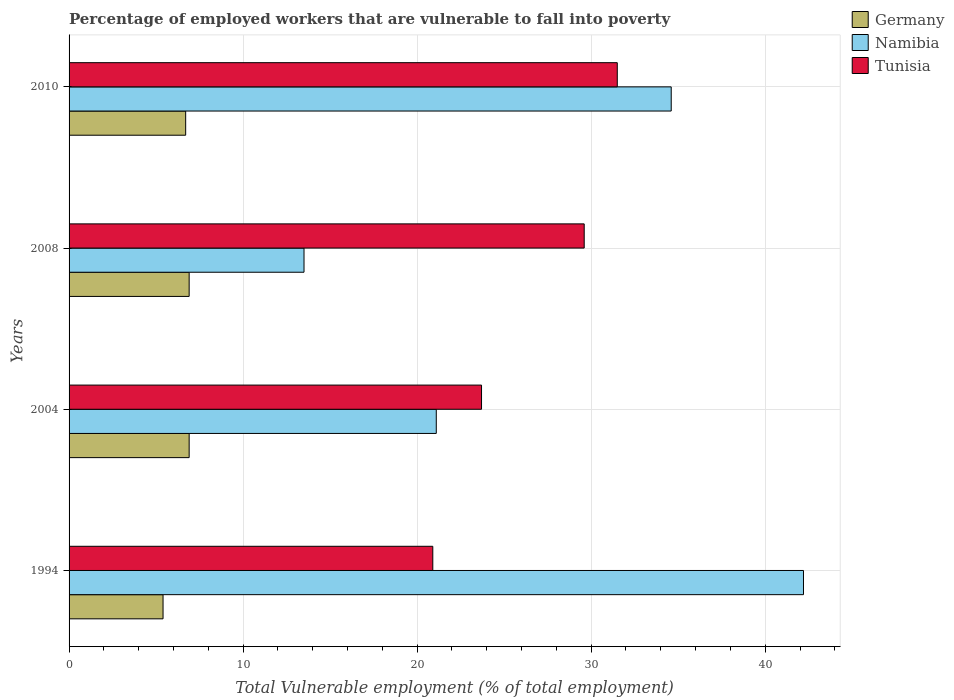Are the number of bars per tick equal to the number of legend labels?
Keep it short and to the point. Yes. How many bars are there on the 3rd tick from the top?
Your response must be concise. 3. How many bars are there on the 3rd tick from the bottom?
Provide a short and direct response. 3. What is the label of the 3rd group of bars from the top?
Offer a terse response. 2004. In how many cases, is the number of bars for a given year not equal to the number of legend labels?
Your response must be concise. 0. What is the percentage of employed workers who are vulnerable to fall into poverty in Germany in 2008?
Offer a very short reply. 6.9. Across all years, what is the maximum percentage of employed workers who are vulnerable to fall into poverty in Namibia?
Give a very brief answer. 42.2. Across all years, what is the minimum percentage of employed workers who are vulnerable to fall into poverty in Tunisia?
Provide a succinct answer. 20.9. In which year was the percentage of employed workers who are vulnerable to fall into poverty in Tunisia minimum?
Your answer should be compact. 1994. What is the total percentage of employed workers who are vulnerable to fall into poverty in Tunisia in the graph?
Provide a short and direct response. 105.7. What is the difference between the percentage of employed workers who are vulnerable to fall into poverty in Tunisia in 1994 and that in 2010?
Give a very brief answer. -10.6. What is the difference between the percentage of employed workers who are vulnerable to fall into poverty in Germany in 2010 and the percentage of employed workers who are vulnerable to fall into poverty in Namibia in 2008?
Give a very brief answer. -6.8. What is the average percentage of employed workers who are vulnerable to fall into poverty in Tunisia per year?
Keep it short and to the point. 26.43. In the year 2010, what is the difference between the percentage of employed workers who are vulnerable to fall into poverty in Germany and percentage of employed workers who are vulnerable to fall into poverty in Tunisia?
Your answer should be compact. -24.8. What is the ratio of the percentage of employed workers who are vulnerable to fall into poverty in Germany in 1994 to that in 2010?
Give a very brief answer. 0.81. Is the percentage of employed workers who are vulnerable to fall into poverty in Tunisia in 1994 less than that in 2004?
Your response must be concise. Yes. What is the difference between the highest and the lowest percentage of employed workers who are vulnerable to fall into poverty in Namibia?
Your answer should be very brief. 28.7. In how many years, is the percentage of employed workers who are vulnerable to fall into poverty in Namibia greater than the average percentage of employed workers who are vulnerable to fall into poverty in Namibia taken over all years?
Make the answer very short. 2. What does the 1st bar from the top in 2008 represents?
Provide a short and direct response. Tunisia. What does the 1st bar from the bottom in 1994 represents?
Your answer should be very brief. Germany. Is it the case that in every year, the sum of the percentage of employed workers who are vulnerable to fall into poverty in Namibia and percentage of employed workers who are vulnerable to fall into poverty in Germany is greater than the percentage of employed workers who are vulnerable to fall into poverty in Tunisia?
Give a very brief answer. No. How many bars are there?
Your answer should be compact. 12. Are all the bars in the graph horizontal?
Provide a short and direct response. Yes. How many years are there in the graph?
Your answer should be very brief. 4. How are the legend labels stacked?
Keep it short and to the point. Vertical. What is the title of the graph?
Make the answer very short. Percentage of employed workers that are vulnerable to fall into poverty. Does "Sweden" appear as one of the legend labels in the graph?
Provide a succinct answer. No. What is the label or title of the X-axis?
Give a very brief answer. Total Vulnerable employment (% of total employment). What is the label or title of the Y-axis?
Offer a terse response. Years. What is the Total Vulnerable employment (% of total employment) in Germany in 1994?
Keep it short and to the point. 5.4. What is the Total Vulnerable employment (% of total employment) of Namibia in 1994?
Keep it short and to the point. 42.2. What is the Total Vulnerable employment (% of total employment) of Tunisia in 1994?
Provide a succinct answer. 20.9. What is the Total Vulnerable employment (% of total employment) of Germany in 2004?
Your answer should be very brief. 6.9. What is the Total Vulnerable employment (% of total employment) in Namibia in 2004?
Provide a short and direct response. 21.1. What is the Total Vulnerable employment (% of total employment) in Tunisia in 2004?
Keep it short and to the point. 23.7. What is the Total Vulnerable employment (% of total employment) of Germany in 2008?
Your answer should be compact. 6.9. What is the Total Vulnerable employment (% of total employment) of Namibia in 2008?
Offer a very short reply. 13.5. What is the Total Vulnerable employment (% of total employment) of Tunisia in 2008?
Your answer should be very brief. 29.6. What is the Total Vulnerable employment (% of total employment) of Germany in 2010?
Your response must be concise. 6.7. What is the Total Vulnerable employment (% of total employment) in Namibia in 2010?
Make the answer very short. 34.6. What is the Total Vulnerable employment (% of total employment) in Tunisia in 2010?
Provide a short and direct response. 31.5. Across all years, what is the maximum Total Vulnerable employment (% of total employment) in Germany?
Offer a terse response. 6.9. Across all years, what is the maximum Total Vulnerable employment (% of total employment) in Namibia?
Ensure brevity in your answer.  42.2. Across all years, what is the maximum Total Vulnerable employment (% of total employment) of Tunisia?
Your answer should be very brief. 31.5. Across all years, what is the minimum Total Vulnerable employment (% of total employment) in Germany?
Offer a terse response. 5.4. Across all years, what is the minimum Total Vulnerable employment (% of total employment) of Namibia?
Your response must be concise. 13.5. Across all years, what is the minimum Total Vulnerable employment (% of total employment) in Tunisia?
Keep it short and to the point. 20.9. What is the total Total Vulnerable employment (% of total employment) of Germany in the graph?
Offer a terse response. 25.9. What is the total Total Vulnerable employment (% of total employment) of Namibia in the graph?
Make the answer very short. 111.4. What is the total Total Vulnerable employment (% of total employment) of Tunisia in the graph?
Give a very brief answer. 105.7. What is the difference between the Total Vulnerable employment (% of total employment) in Namibia in 1994 and that in 2004?
Your answer should be compact. 21.1. What is the difference between the Total Vulnerable employment (% of total employment) of Namibia in 1994 and that in 2008?
Provide a short and direct response. 28.7. What is the difference between the Total Vulnerable employment (% of total employment) in Tunisia in 1994 and that in 2008?
Make the answer very short. -8.7. What is the difference between the Total Vulnerable employment (% of total employment) of Germany in 1994 and that in 2010?
Give a very brief answer. -1.3. What is the difference between the Total Vulnerable employment (% of total employment) of Namibia in 1994 and that in 2010?
Provide a short and direct response. 7.6. What is the difference between the Total Vulnerable employment (% of total employment) in Tunisia in 1994 and that in 2010?
Offer a terse response. -10.6. What is the difference between the Total Vulnerable employment (% of total employment) of Tunisia in 2004 and that in 2008?
Provide a succinct answer. -5.9. What is the difference between the Total Vulnerable employment (% of total employment) of Tunisia in 2004 and that in 2010?
Provide a short and direct response. -7.8. What is the difference between the Total Vulnerable employment (% of total employment) in Namibia in 2008 and that in 2010?
Offer a terse response. -21.1. What is the difference between the Total Vulnerable employment (% of total employment) in Tunisia in 2008 and that in 2010?
Provide a short and direct response. -1.9. What is the difference between the Total Vulnerable employment (% of total employment) in Germany in 1994 and the Total Vulnerable employment (% of total employment) in Namibia in 2004?
Offer a terse response. -15.7. What is the difference between the Total Vulnerable employment (% of total employment) in Germany in 1994 and the Total Vulnerable employment (% of total employment) in Tunisia in 2004?
Give a very brief answer. -18.3. What is the difference between the Total Vulnerable employment (% of total employment) of Namibia in 1994 and the Total Vulnerable employment (% of total employment) of Tunisia in 2004?
Give a very brief answer. 18.5. What is the difference between the Total Vulnerable employment (% of total employment) in Germany in 1994 and the Total Vulnerable employment (% of total employment) in Namibia in 2008?
Keep it short and to the point. -8.1. What is the difference between the Total Vulnerable employment (% of total employment) of Germany in 1994 and the Total Vulnerable employment (% of total employment) of Tunisia in 2008?
Give a very brief answer. -24.2. What is the difference between the Total Vulnerable employment (% of total employment) of Namibia in 1994 and the Total Vulnerable employment (% of total employment) of Tunisia in 2008?
Ensure brevity in your answer.  12.6. What is the difference between the Total Vulnerable employment (% of total employment) in Germany in 1994 and the Total Vulnerable employment (% of total employment) in Namibia in 2010?
Provide a succinct answer. -29.2. What is the difference between the Total Vulnerable employment (% of total employment) of Germany in 1994 and the Total Vulnerable employment (% of total employment) of Tunisia in 2010?
Offer a terse response. -26.1. What is the difference between the Total Vulnerable employment (% of total employment) in Germany in 2004 and the Total Vulnerable employment (% of total employment) in Tunisia in 2008?
Keep it short and to the point. -22.7. What is the difference between the Total Vulnerable employment (% of total employment) in Germany in 2004 and the Total Vulnerable employment (% of total employment) in Namibia in 2010?
Your response must be concise. -27.7. What is the difference between the Total Vulnerable employment (% of total employment) in Germany in 2004 and the Total Vulnerable employment (% of total employment) in Tunisia in 2010?
Keep it short and to the point. -24.6. What is the difference between the Total Vulnerable employment (% of total employment) of Namibia in 2004 and the Total Vulnerable employment (% of total employment) of Tunisia in 2010?
Offer a terse response. -10.4. What is the difference between the Total Vulnerable employment (% of total employment) of Germany in 2008 and the Total Vulnerable employment (% of total employment) of Namibia in 2010?
Keep it short and to the point. -27.7. What is the difference between the Total Vulnerable employment (% of total employment) of Germany in 2008 and the Total Vulnerable employment (% of total employment) of Tunisia in 2010?
Provide a succinct answer. -24.6. What is the average Total Vulnerable employment (% of total employment) in Germany per year?
Provide a short and direct response. 6.47. What is the average Total Vulnerable employment (% of total employment) in Namibia per year?
Keep it short and to the point. 27.85. What is the average Total Vulnerable employment (% of total employment) in Tunisia per year?
Provide a succinct answer. 26.43. In the year 1994, what is the difference between the Total Vulnerable employment (% of total employment) in Germany and Total Vulnerable employment (% of total employment) in Namibia?
Give a very brief answer. -36.8. In the year 1994, what is the difference between the Total Vulnerable employment (% of total employment) in Germany and Total Vulnerable employment (% of total employment) in Tunisia?
Ensure brevity in your answer.  -15.5. In the year 1994, what is the difference between the Total Vulnerable employment (% of total employment) of Namibia and Total Vulnerable employment (% of total employment) of Tunisia?
Make the answer very short. 21.3. In the year 2004, what is the difference between the Total Vulnerable employment (% of total employment) in Germany and Total Vulnerable employment (% of total employment) in Namibia?
Provide a short and direct response. -14.2. In the year 2004, what is the difference between the Total Vulnerable employment (% of total employment) in Germany and Total Vulnerable employment (% of total employment) in Tunisia?
Offer a terse response. -16.8. In the year 2004, what is the difference between the Total Vulnerable employment (% of total employment) of Namibia and Total Vulnerable employment (% of total employment) of Tunisia?
Provide a succinct answer. -2.6. In the year 2008, what is the difference between the Total Vulnerable employment (% of total employment) of Germany and Total Vulnerable employment (% of total employment) of Tunisia?
Your answer should be compact. -22.7. In the year 2008, what is the difference between the Total Vulnerable employment (% of total employment) of Namibia and Total Vulnerable employment (% of total employment) of Tunisia?
Ensure brevity in your answer.  -16.1. In the year 2010, what is the difference between the Total Vulnerable employment (% of total employment) in Germany and Total Vulnerable employment (% of total employment) in Namibia?
Your answer should be very brief. -27.9. In the year 2010, what is the difference between the Total Vulnerable employment (% of total employment) of Germany and Total Vulnerable employment (% of total employment) of Tunisia?
Your answer should be very brief. -24.8. What is the ratio of the Total Vulnerable employment (% of total employment) in Germany in 1994 to that in 2004?
Offer a very short reply. 0.78. What is the ratio of the Total Vulnerable employment (% of total employment) in Tunisia in 1994 to that in 2004?
Give a very brief answer. 0.88. What is the ratio of the Total Vulnerable employment (% of total employment) in Germany in 1994 to that in 2008?
Your answer should be very brief. 0.78. What is the ratio of the Total Vulnerable employment (% of total employment) in Namibia in 1994 to that in 2008?
Provide a succinct answer. 3.13. What is the ratio of the Total Vulnerable employment (% of total employment) in Tunisia in 1994 to that in 2008?
Your response must be concise. 0.71. What is the ratio of the Total Vulnerable employment (% of total employment) in Germany in 1994 to that in 2010?
Offer a terse response. 0.81. What is the ratio of the Total Vulnerable employment (% of total employment) of Namibia in 1994 to that in 2010?
Ensure brevity in your answer.  1.22. What is the ratio of the Total Vulnerable employment (% of total employment) of Tunisia in 1994 to that in 2010?
Provide a short and direct response. 0.66. What is the ratio of the Total Vulnerable employment (% of total employment) of Namibia in 2004 to that in 2008?
Make the answer very short. 1.56. What is the ratio of the Total Vulnerable employment (% of total employment) in Tunisia in 2004 to that in 2008?
Offer a very short reply. 0.8. What is the ratio of the Total Vulnerable employment (% of total employment) in Germany in 2004 to that in 2010?
Keep it short and to the point. 1.03. What is the ratio of the Total Vulnerable employment (% of total employment) of Namibia in 2004 to that in 2010?
Your response must be concise. 0.61. What is the ratio of the Total Vulnerable employment (% of total employment) in Tunisia in 2004 to that in 2010?
Offer a terse response. 0.75. What is the ratio of the Total Vulnerable employment (% of total employment) of Germany in 2008 to that in 2010?
Keep it short and to the point. 1.03. What is the ratio of the Total Vulnerable employment (% of total employment) of Namibia in 2008 to that in 2010?
Provide a short and direct response. 0.39. What is the ratio of the Total Vulnerable employment (% of total employment) in Tunisia in 2008 to that in 2010?
Keep it short and to the point. 0.94. What is the difference between the highest and the second highest Total Vulnerable employment (% of total employment) in Germany?
Offer a terse response. 0. What is the difference between the highest and the second highest Total Vulnerable employment (% of total employment) of Tunisia?
Keep it short and to the point. 1.9. What is the difference between the highest and the lowest Total Vulnerable employment (% of total employment) in Germany?
Your response must be concise. 1.5. What is the difference between the highest and the lowest Total Vulnerable employment (% of total employment) of Namibia?
Your response must be concise. 28.7. What is the difference between the highest and the lowest Total Vulnerable employment (% of total employment) in Tunisia?
Offer a very short reply. 10.6. 